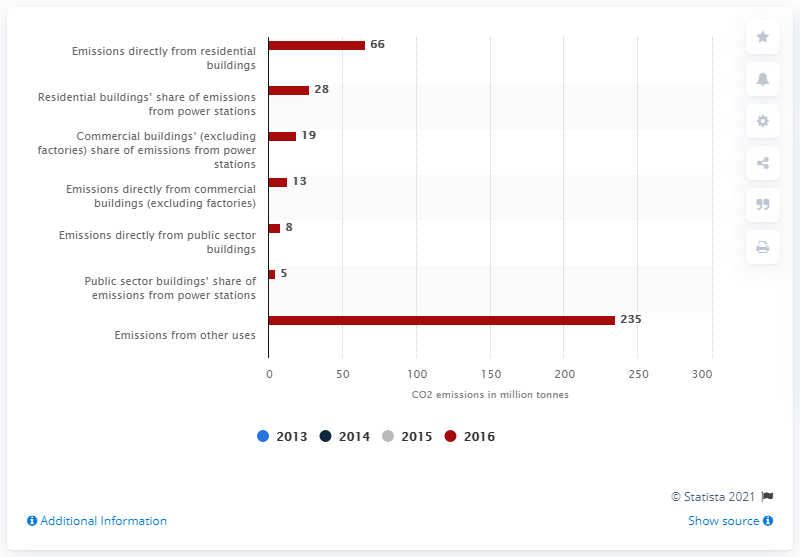Draw attention to some important aspects in this diagram. In 2016, residential buildings emitted approximately 66 tonnes of CO2 emissions. 